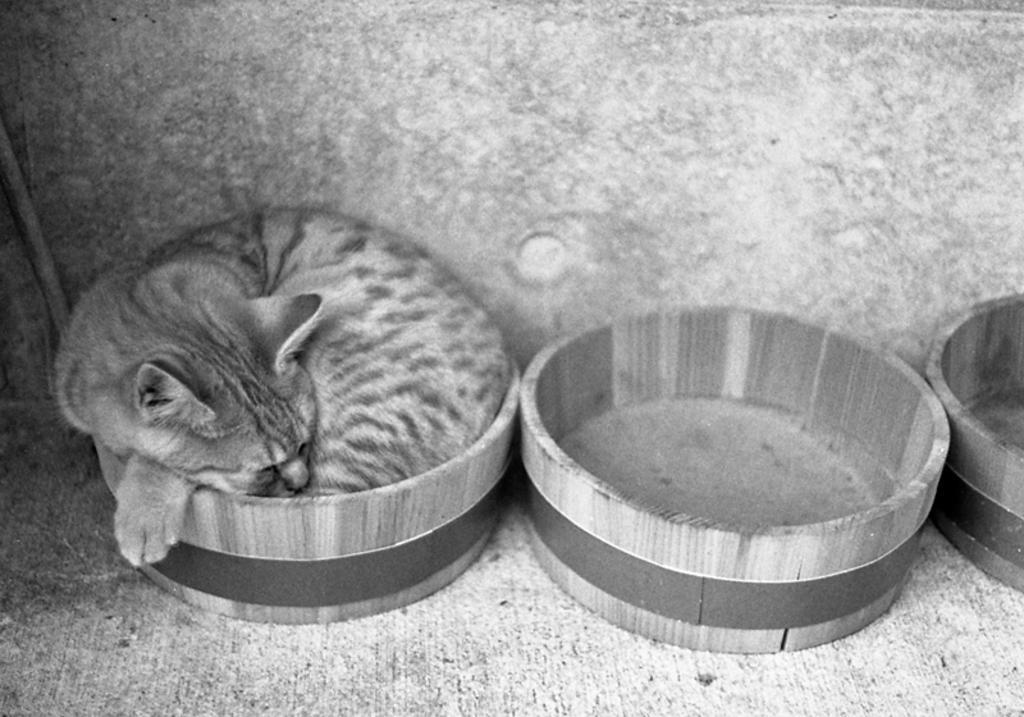Describe this image in one or two sentences. This is a black and white image. In this image we can see wooden objects. Inside the wooden object there is a cat. In the back there is a wall. 